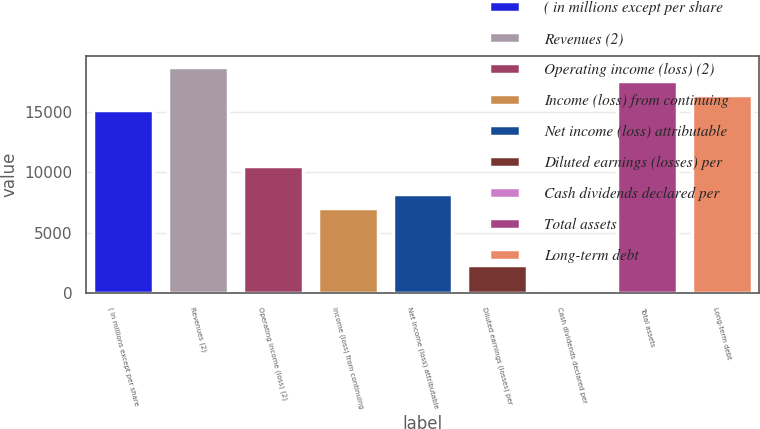<chart> <loc_0><loc_0><loc_500><loc_500><bar_chart><fcel>( in millions except per share<fcel>Revenues (2)<fcel>Operating income (loss) (2)<fcel>Income (loss) from continuing<fcel>Net income (loss) attributable<fcel>Diluted earnings (losses) per<fcel>Cash dividends declared per<fcel>Total assets<fcel>Long-term debt<nl><fcel>15198.2<fcel>18705.5<fcel>10521.9<fcel>7014.69<fcel>8183.77<fcel>2338.37<fcel>0.21<fcel>17536.4<fcel>16367.3<nl></chart> 